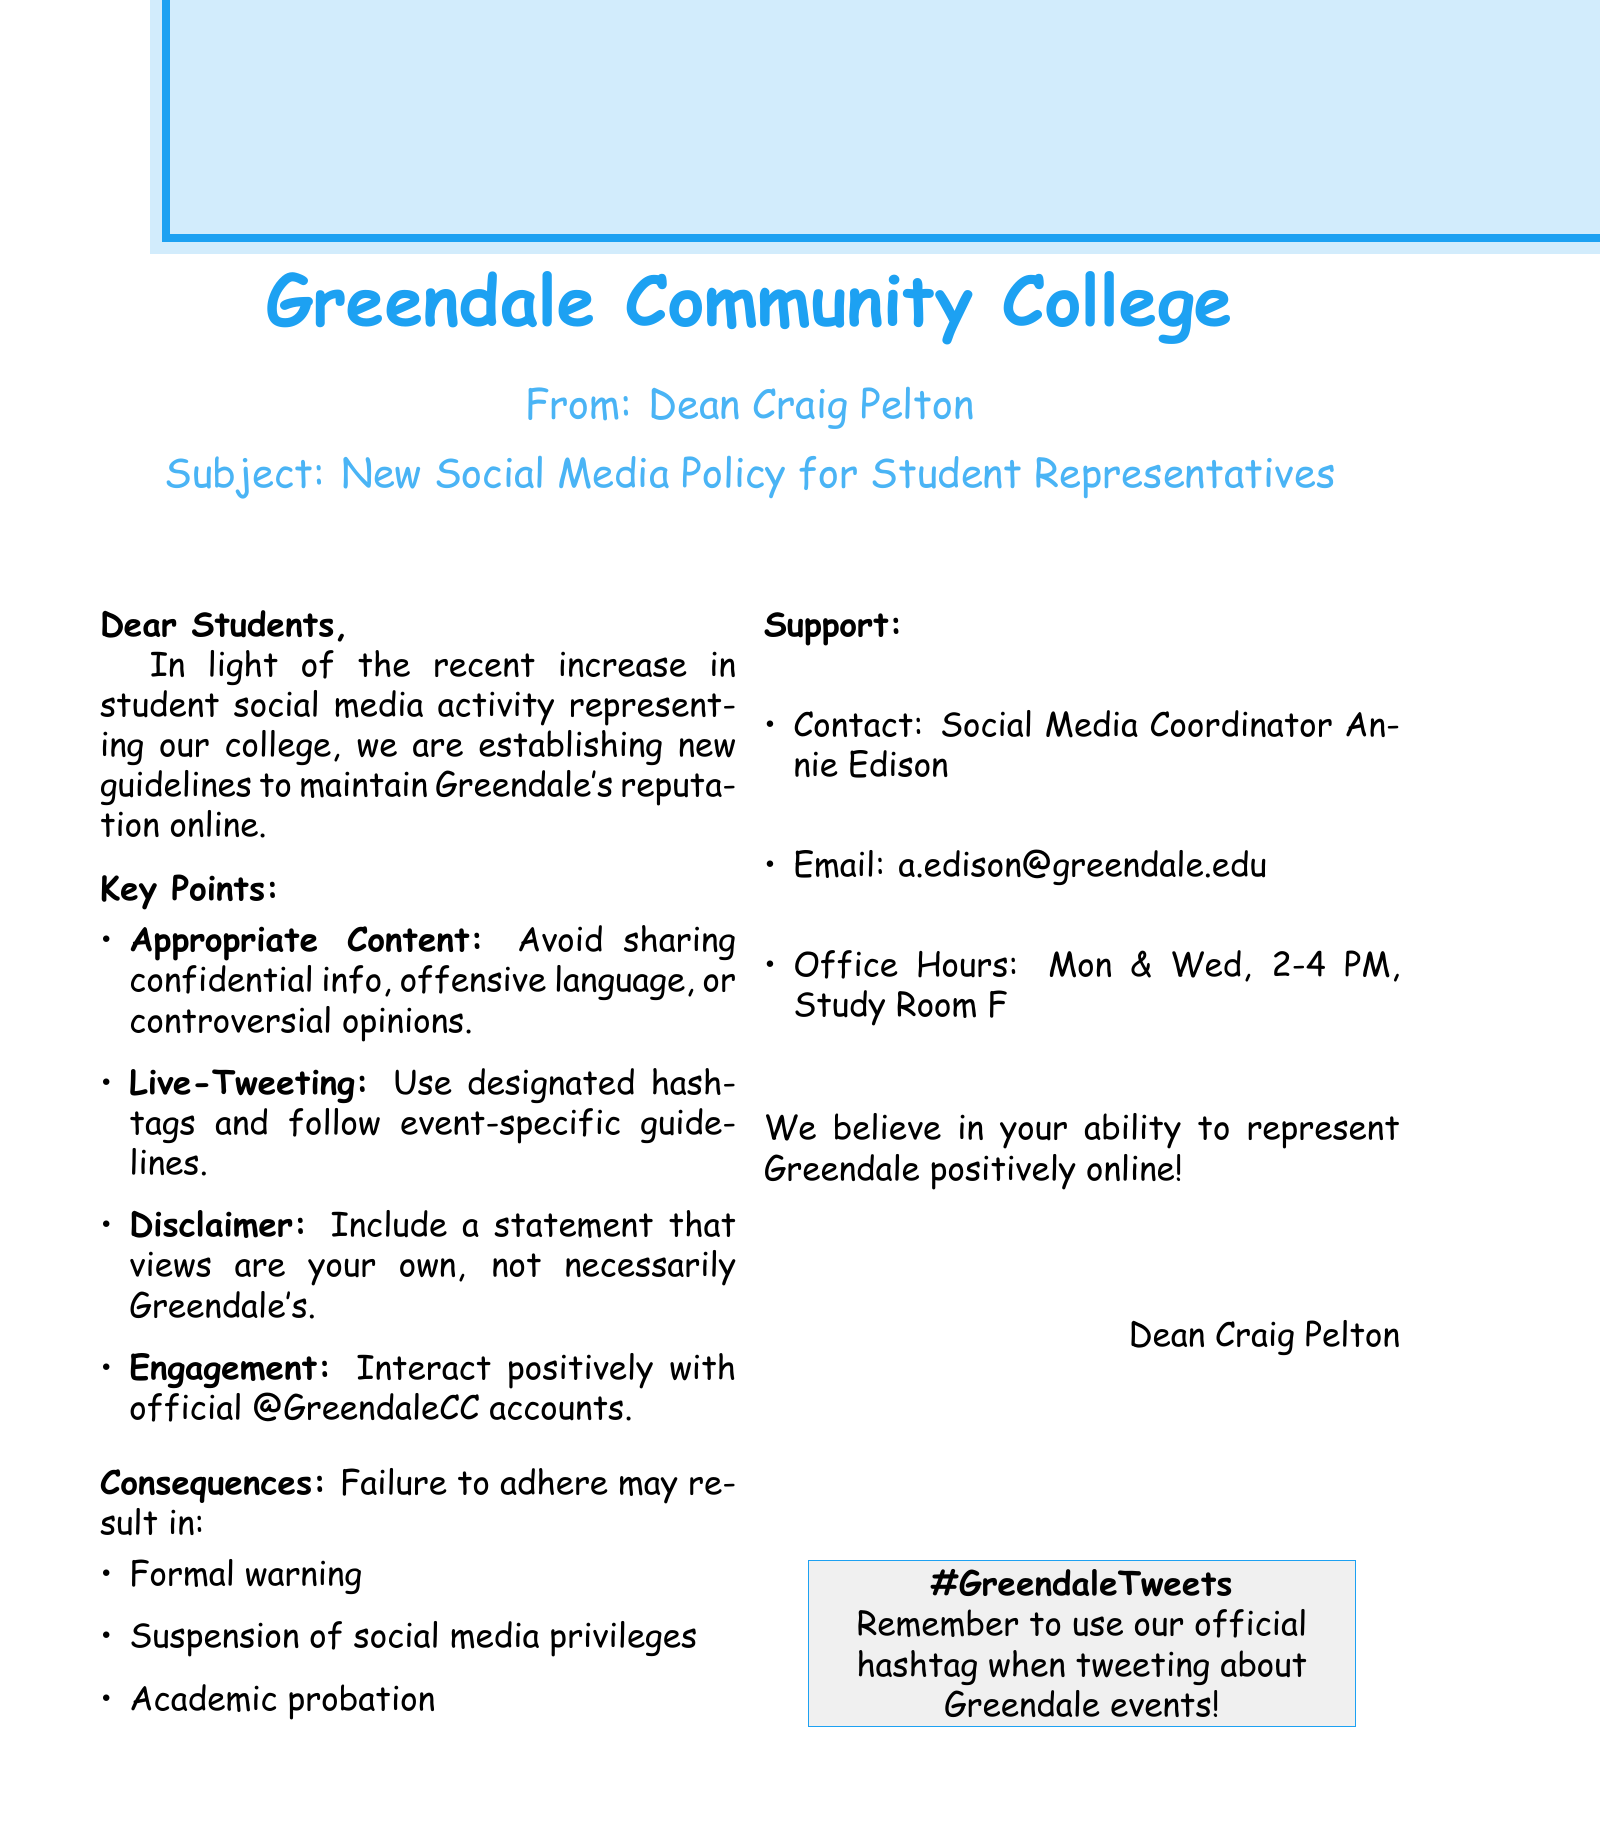What is the name of the dean? The dean's name is mentioned at the top of the document.
Answer: Dean Craig Pelton What is the subject of the letter? The subject line in the header provides the main topic of the letter.
Answer: New Social Media Policy for Student Representatives What should be avoided when posting on social media? The document outlines inappropriate content that should be avoided in a specific section.
Answer: Confidential information, offensive language, or controversial opinions Who is the contact person for support? The document provides a contact for questions about the policy.
Answer: Social Media Coordinator Annie Edison When are the office hours for support? The office hours for the support contact are listed in the support section.
Answer: Mondays and Wednesdays, 2-4 PM What may happen if these guidelines are violated? The document outlines consequences that can result from not following the guidelines.
Answer: Disciplinary action What should students do when live-tweeting events? The guidelines specify what actions to take for live-tweeting university events.
Answer: Use designated hashtags and follow event-specific guidelines What must students include in their bios? The document specifies the content that should be included in students' social media bios.
Answer: A statement clarifying that views expressed are your own and not necessarily those of Greendale Community College 